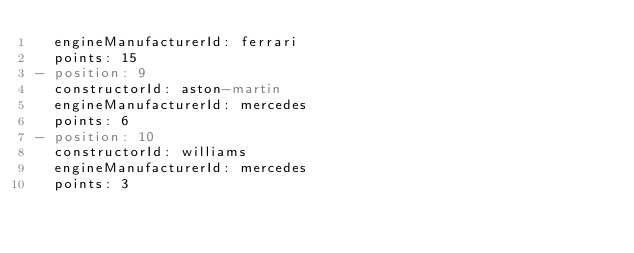<code> <loc_0><loc_0><loc_500><loc_500><_YAML_>  engineManufacturerId: ferrari
  points: 15
- position: 9
  constructorId: aston-martin
  engineManufacturerId: mercedes
  points: 6
- position: 10
  constructorId: williams
  engineManufacturerId: mercedes
  points: 3
</code> 